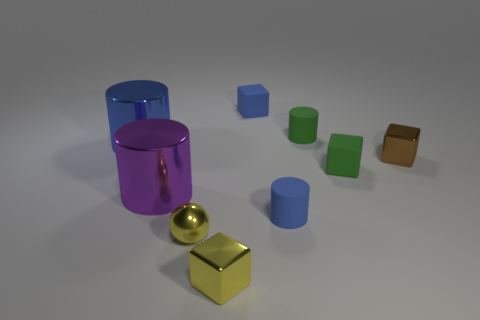Subtract 1 cubes. How many cubes are left? 3 Subtract all cyan blocks. Subtract all purple cylinders. How many blocks are left? 4 Add 1 matte objects. How many objects exist? 10 Subtract all cylinders. How many objects are left? 5 Subtract 0 red blocks. How many objects are left? 9 Subtract all tiny yellow blocks. Subtract all tiny rubber blocks. How many objects are left? 6 Add 1 blue rubber cubes. How many blue rubber cubes are left? 2 Add 4 tiny rubber cylinders. How many tiny rubber cylinders exist? 6 